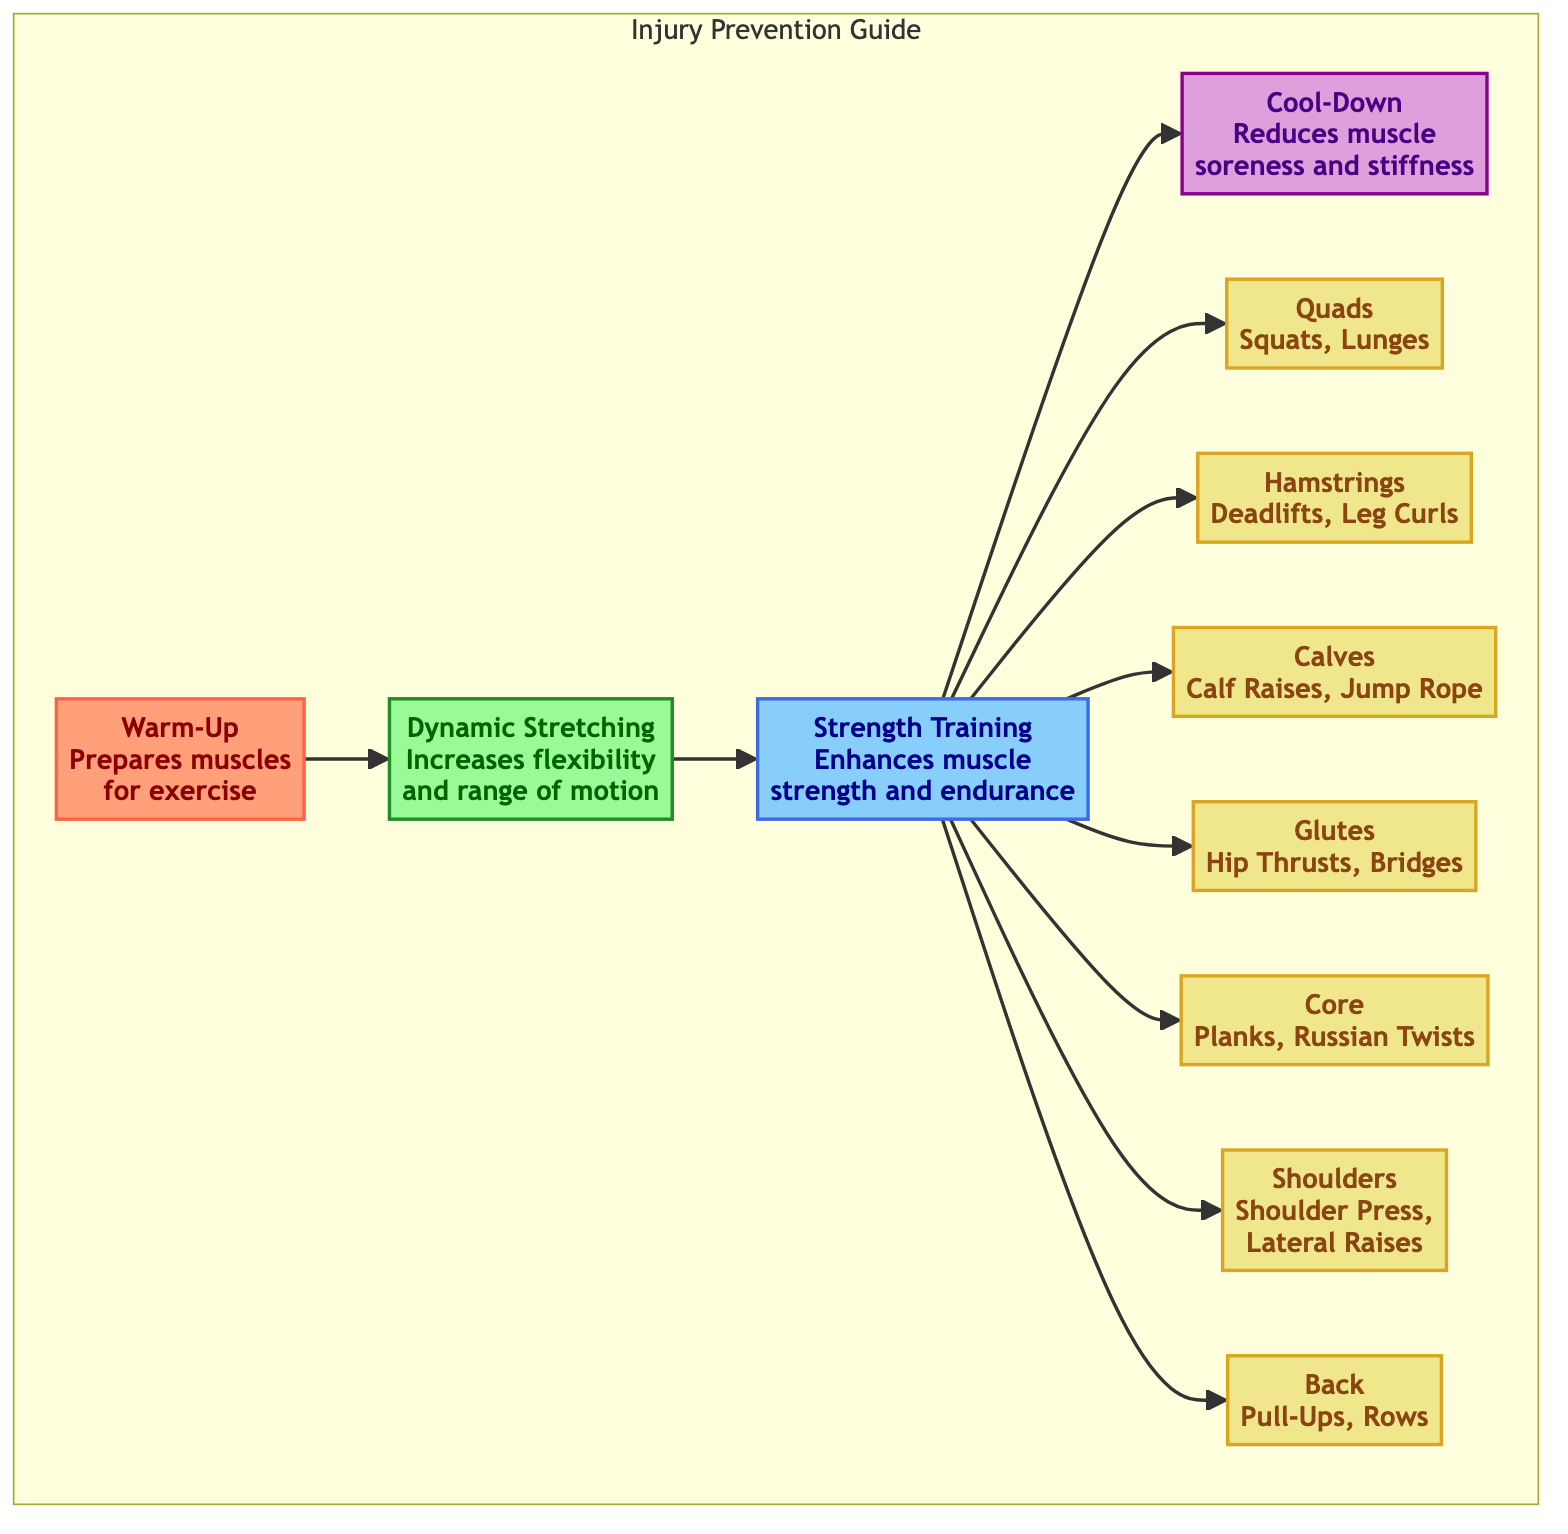What's the first step in the exercise sequence? The diagram indicates that the first step is "Warm-Up," which is the initial node before any other activities. This is the first node in the flowchart.
Answer: Warm-Up How many muscle groups are targeted during strength training? The diagram shows that strength training connects to six distinct muscle groups: Quads, Hamstrings, Calves, Glutes, Core, Shoulders, and Back. By counting these, we find there are seven muscle groups targeted.
Answer: Seven What does "Dynamic Stretching" increase? According to the diagram, "Dynamic Stretching" is noted to increase flexibility and range of motion, specifically indicated in the description connected to that node.
Answer: Flexibility and range of motion Which exercise is associated with the "Glutes" muscle group? The diagram provides two exercise examples associated with the "Glutes" muscle group: Hip Thrusts and Bridges, as listed directly under the Glutes node.
Answer: Hip Thrusts, Bridges What is the last step in the exercise sequence? Following the flow of the diagram, the last step in the exercise sequence is labeled as "Cool-Down," directly after the strength training exercises.
Answer: Cool-Down How many total steps are there in the injury prevention guide? The diagram outlines four main steps: Warm-Up, Dynamic Stretching, Strength Training, and Cool-Down, leading us to a total of four distinct steps in the guide.
Answer: Four Which muscle group is associated with the exercises "Pull-Ups" and "Rows"? "Pull-Ups" and "Rows" are specifically associated with the "Back" muscle group, as detailed in the description connected to that muscle group node.
Answer: Back What exercises are related to the "Core" muscle group? The diagram lists "Planks" and "Russian Twists" as exercises for the "Core" muscle group, which can be found in the description of the Core node.
Answer: Planks, Russian Twists 